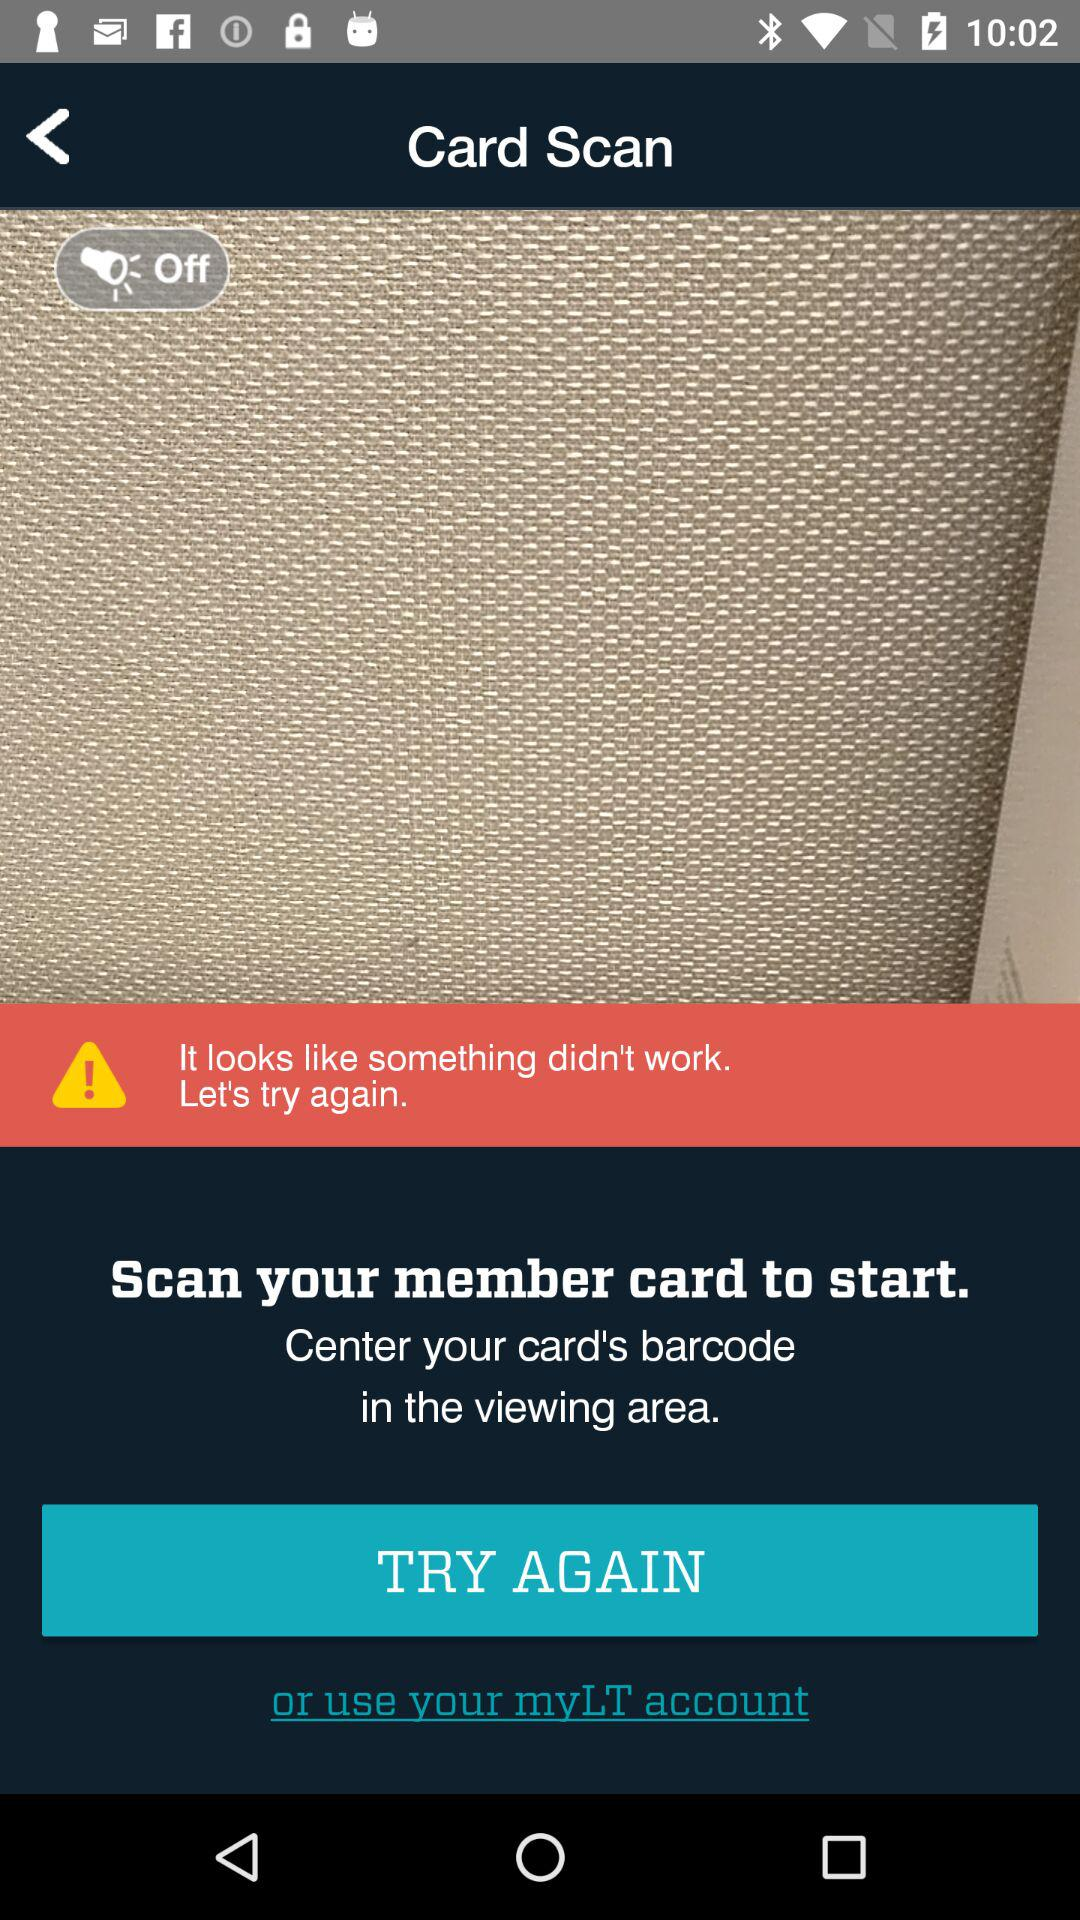What's the setting for the "torch" button? The setting for the "torch" button is "Off". 